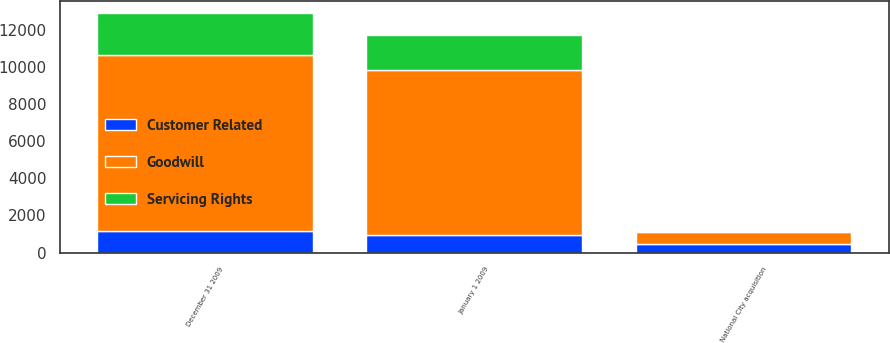Convert chart. <chart><loc_0><loc_0><loc_500><loc_500><stacked_bar_chart><ecel><fcel>January 1 2009<fcel>National City acquisition<fcel>December 31 2009<nl><fcel>Goodwill<fcel>8868<fcel>647<fcel>9505<nl><fcel>Customer Related<fcel>930<fcel>451<fcel>1145<nl><fcel>Servicing Rights<fcel>1890<fcel>18<fcel>2259<nl></chart> 